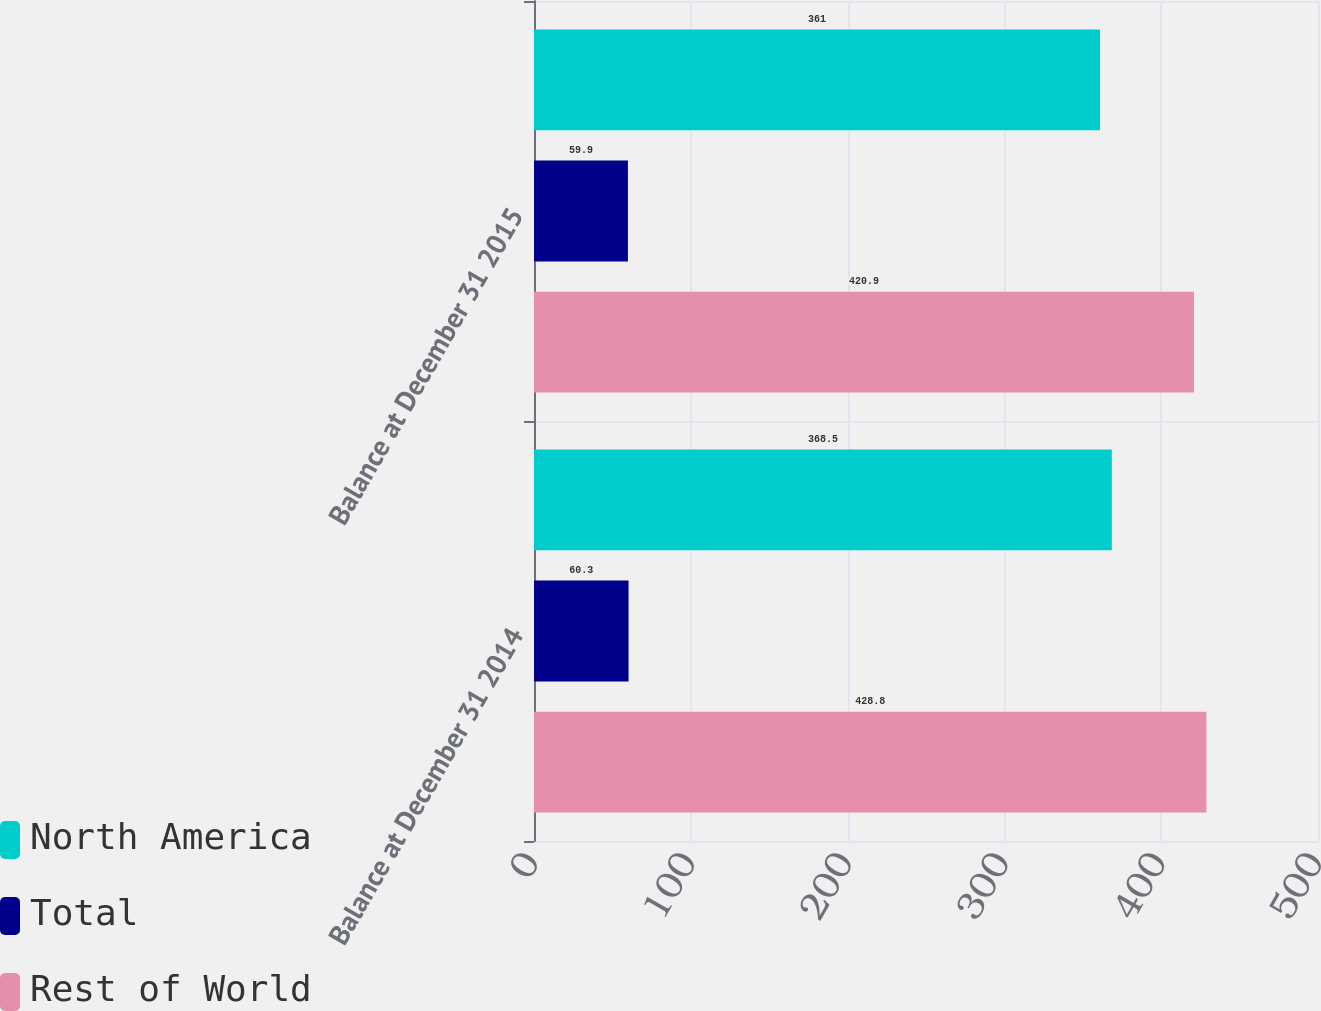Convert chart. <chart><loc_0><loc_0><loc_500><loc_500><stacked_bar_chart><ecel><fcel>Balance at December 31 2014<fcel>Balance at December 31 2015<nl><fcel>North America<fcel>368.5<fcel>361<nl><fcel>Total<fcel>60.3<fcel>59.9<nl><fcel>Rest of World<fcel>428.8<fcel>420.9<nl></chart> 